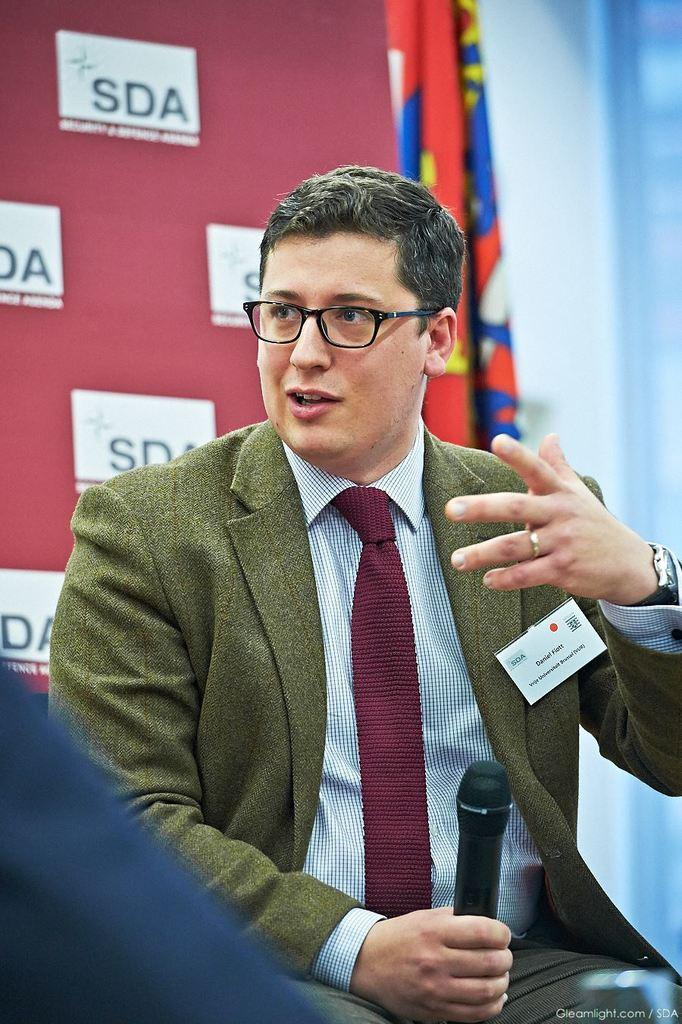What is the man in the image doing? The man is holding a microphone and his mouth is open, suggesting he is talking. What can be seen in the background of the image? There are curtains and a red-colored hoarding in the background of the image. What type of plough is the man using in the image? There is no plough present in the image; the man is holding a microphone and talking. Can you tell me what the man's father is doing in the image? There is no information about the man's father in the image, as it only shows the man holding a microphone and talking. 